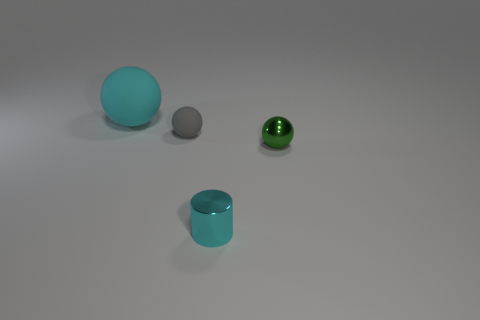Subtract all purple spheres. Subtract all purple cylinders. How many spheres are left? 3 Add 1 tiny cylinders. How many objects exist? 5 Subtract all balls. How many objects are left? 1 Subtract 0 green blocks. How many objects are left? 4 Subtract all shiny spheres. Subtract all tiny balls. How many objects are left? 1 Add 4 tiny gray matte things. How many tiny gray matte things are left? 5 Add 2 small matte things. How many small matte things exist? 3 